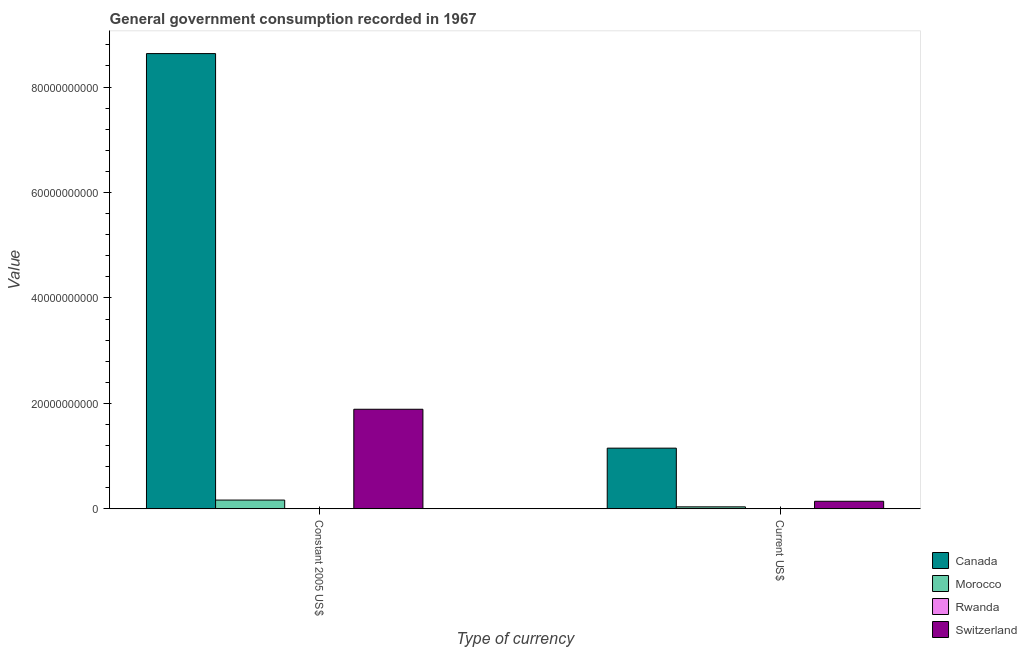Are the number of bars per tick equal to the number of legend labels?
Keep it short and to the point. Yes. How many bars are there on the 2nd tick from the left?
Offer a very short reply. 4. What is the label of the 1st group of bars from the left?
Offer a very short reply. Constant 2005 US$. What is the value consumed in current us$ in Switzerland?
Your response must be concise. 1.44e+09. Across all countries, what is the maximum value consumed in current us$?
Make the answer very short. 1.15e+1. Across all countries, what is the minimum value consumed in constant 2005 us$?
Your answer should be very brief. 4.54e+07. In which country was the value consumed in constant 2005 us$ maximum?
Keep it short and to the point. Canada. In which country was the value consumed in current us$ minimum?
Offer a very short reply. Rwanda. What is the total value consumed in current us$ in the graph?
Offer a terse response. 1.33e+1. What is the difference between the value consumed in constant 2005 us$ in Rwanda and that in Canada?
Your answer should be very brief. -8.63e+1. What is the difference between the value consumed in current us$ in Canada and the value consumed in constant 2005 us$ in Morocco?
Ensure brevity in your answer.  9.85e+09. What is the average value consumed in constant 2005 us$ per country?
Provide a succinct answer. 2.67e+1. What is the difference between the value consumed in constant 2005 us$ and value consumed in current us$ in Switzerland?
Your answer should be very brief. 1.75e+1. What is the ratio of the value consumed in current us$ in Canada to that in Switzerland?
Ensure brevity in your answer.  8.02. Is the value consumed in constant 2005 us$ in Rwanda less than that in Canada?
Offer a very short reply. Yes. What does the 1st bar from the left in Current US$ represents?
Offer a very short reply. Canada. How many bars are there?
Provide a short and direct response. 8. Are all the bars in the graph horizontal?
Offer a very short reply. No. How many countries are there in the graph?
Give a very brief answer. 4. What is the difference between two consecutive major ticks on the Y-axis?
Give a very brief answer. 2.00e+1. Are the values on the major ticks of Y-axis written in scientific E-notation?
Your response must be concise. No. Does the graph contain grids?
Keep it short and to the point. No. Where does the legend appear in the graph?
Make the answer very short. Bottom right. How are the legend labels stacked?
Your answer should be compact. Vertical. What is the title of the graph?
Your response must be concise. General government consumption recorded in 1967. Does "Ethiopia" appear as one of the legend labels in the graph?
Ensure brevity in your answer.  No. What is the label or title of the X-axis?
Your answer should be compact. Type of currency. What is the label or title of the Y-axis?
Keep it short and to the point. Value. What is the Value in Canada in Constant 2005 US$?
Give a very brief answer. 8.63e+1. What is the Value of Morocco in Constant 2005 US$?
Give a very brief answer. 1.66e+09. What is the Value of Rwanda in Constant 2005 US$?
Your response must be concise. 4.54e+07. What is the Value in Switzerland in Constant 2005 US$?
Give a very brief answer. 1.89e+1. What is the Value in Canada in Current US$?
Your response must be concise. 1.15e+1. What is the Value in Morocco in Current US$?
Provide a short and direct response. 3.79e+08. What is the Value of Rwanda in Current US$?
Your answer should be compact. 1.80e+07. What is the Value in Switzerland in Current US$?
Offer a terse response. 1.44e+09. Across all Type of currency, what is the maximum Value of Canada?
Keep it short and to the point. 8.63e+1. Across all Type of currency, what is the maximum Value in Morocco?
Keep it short and to the point. 1.66e+09. Across all Type of currency, what is the maximum Value in Rwanda?
Keep it short and to the point. 4.54e+07. Across all Type of currency, what is the maximum Value of Switzerland?
Provide a short and direct response. 1.89e+1. Across all Type of currency, what is the minimum Value of Canada?
Provide a short and direct response. 1.15e+1. Across all Type of currency, what is the minimum Value in Morocco?
Provide a short and direct response. 3.79e+08. Across all Type of currency, what is the minimum Value in Rwanda?
Keep it short and to the point. 1.80e+07. Across all Type of currency, what is the minimum Value of Switzerland?
Your answer should be very brief. 1.44e+09. What is the total Value in Canada in the graph?
Your response must be concise. 9.79e+1. What is the total Value of Morocco in the graph?
Keep it short and to the point. 2.04e+09. What is the total Value of Rwanda in the graph?
Ensure brevity in your answer.  6.35e+07. What is the total Value of Switzerland in the graph?
Offer a very short reply. 2.03e+1. What is the difference between the Value in Canada in Constant 2005 US$ and that in Current US$?
Provide a succinct answer. 7.48e+1. What is the difference between the Value of Morocco in Constant 2005 US$ and that in Current US$?
Keep it short and to the point. 1.28e+09. What is the difference between the Value of Rwanda in Constant 2005 US$ and that in Current US$?
Offer a terse response. 2.74e+07. What is the difference between the Value of Switzerland in Constant 2005 US$ and that in Current US$?
Keep it short and to the point. 1.75e+1. What is the difference between the Value of Canada in Constant 2005 US$ and the Value of Morocco in Current US$?
Your answer should be compact. 8.60e+1. What is the difference between the Value of Canada in Constant 2005 US$ and the Value of Rwanda in Current US$?
Give a very brief answer. 8.63e+1. What is the difference between the Value in Canada in Constant 2005 US$ and the Value in Switzerland in Current US$?
Offer a very short reply. 8.49e+1. What is the difference between the Value in Morocco in Constant 2005 US$ and the Value in Rwanda in Current US$?
Offer a terse response. 1.65e+09. What is the difference between the Value of Morocco in Constant 2005 US$ and the Value of Switzerland in Current US$?
Offer a very short reply. 2.28e+08. What is the difference between the Value of Rwanda in Constant 2005 US$ and the Value of Switzerland in Current US$?
Your response must be concise. -1.39e+09. What is the average Value in Canada per Type of currency?
Make the answer very short. 4.89e+1. What is the average Value of Morocco per Type of currency?
Offer a terse response. 1.02e+09. What is the average Value of Rwanda per Type of currency?
Offer a terse response. 3.17e+07. What is the average Value in Switzerland per Type of currency?
Your answer should be compact. 1.02e+1. What is the difference between the Value in Canada and Value in Morocco in Constant 2005 US$?
Offer a very short reply. 8.47e+1. What is the difference between the Value in Canada and Value in Rwanda in Constant 2005 US$?
Your answer should be very brief. 8.63e+1. What is the difference between the Value of Canada and Value of Switzerland in Constant 2005 US$?
Give a very brief answer. 6.75e+1. What is the difference between the Value in Morocco and Value in Rwanda in Constant 2005 US$?
Give a very brief answer. 1.62e+09. What is the difference between the Value in Morocco and Value in Switzerland in Constant 2005 US$?
Your response must be concise. -1.72e+1. What is the difference between the Value of Rwanda and Value of Switzerland in Constant 2005 US$?
Ensure brevity in your answer.  -1.88e+1. What is the difference between the Value of Canada and Value of Morocco in Current US$?
Make the answer very short. 1.11e+1. What is the difference between the Value of Canada and Value of Rwanda in Current US$?
Your response must be concise. 1.15e+1. What is the difference between the Value of Canada and Value of Switzerland in Current US$?
Your response must be concise. 1.01e+1. What is the difference between the Value of Morocco and Value of Rwanda in Current US$?
Your answer should be compact. 3.61e+08. What is the difference between the Value in Morocco and Value in Switzerland in Current US$?
Make the answer very short. -1.06e+09. What is the difference between the Value in Rwanda and Value in Switzerland in Current US$?
Your answer should be compact. -1.42e+09. What is the ratio of the Value in Canada in Constant 2005 US$ to that in Current US$?
Offer a terse response. 7.5. What is the ratio of the Value in Morocco in Constant 2005 US$ to that in Current US$?
Your response must be concise. 4.38. What is the ratio of the Value of Rwanda in Constant 2005 US$ to that in Current US$?
Keep it short and to the point. 2.52. What is the ratio of the Value in Switzerland in Constant 2005 US$ to that in Current US$?
Offer a very short reply. 13.16. What is the difference between the highest and the second highest Value of Canada?
Provide a short and direct response. 7.48e+1. What is the difference between the highest and the second highest Value of Morocco?
Provide a short and direct response. 1.28e+09. What is the difference between the highest and the second highest Value in Rwanda?
Offer a terse response. 2.74e+07. What is the difference between the highest and the second highest Value of Switzerland?
Make the answer very short. 1.75e+1. What is the difference between the highest and the lowest Value in Canada?
Your response must be concise. 7.48e+1. What is the difference between the highest and the lowest Value of Morocco?
Your answer should be compact. 1.28e+09. What is the difference between the highest and the lowest Value in Rwanda?
Your answer should be very brief. 2.74e+07. What is the difference between the highest and the lowest Value in Switzerland?
Your answer should be compact. 1.75e+1. 